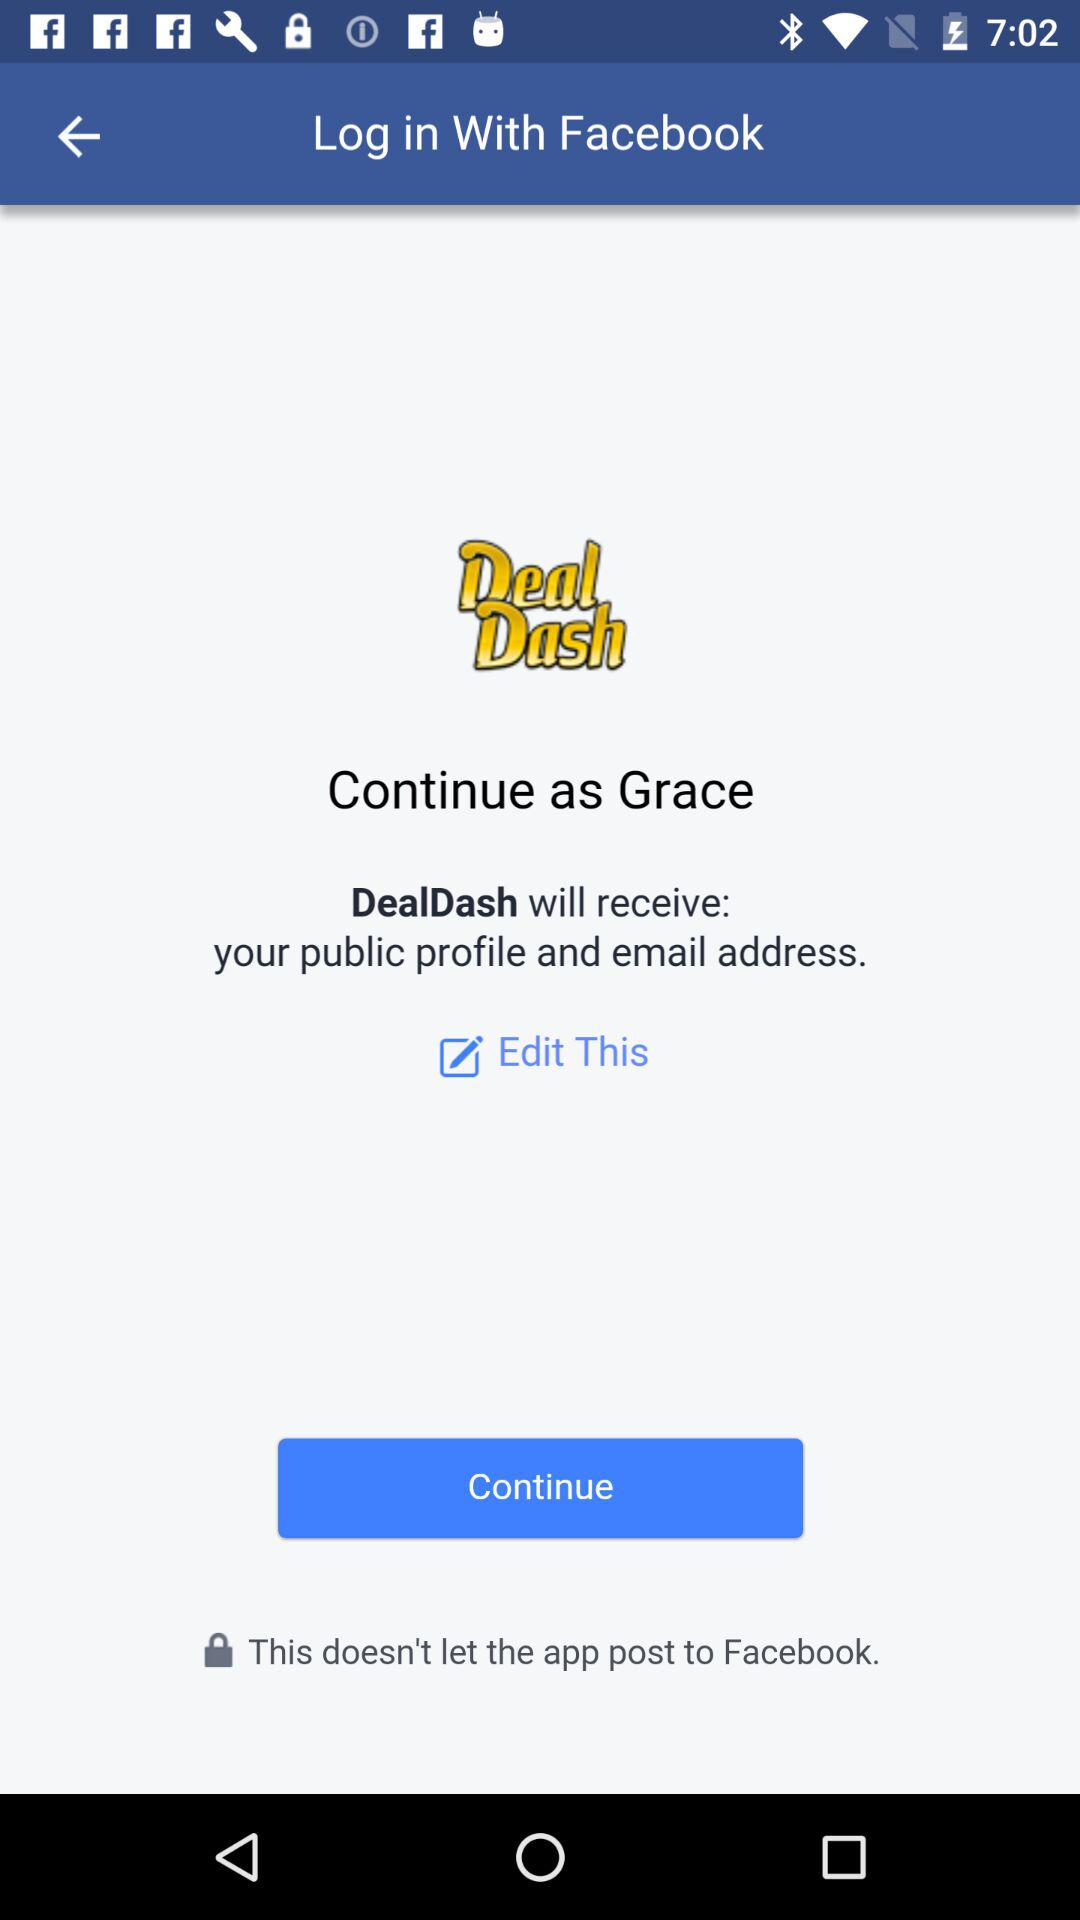What application is asking for permission? The application asking for permission is "DealDash". 